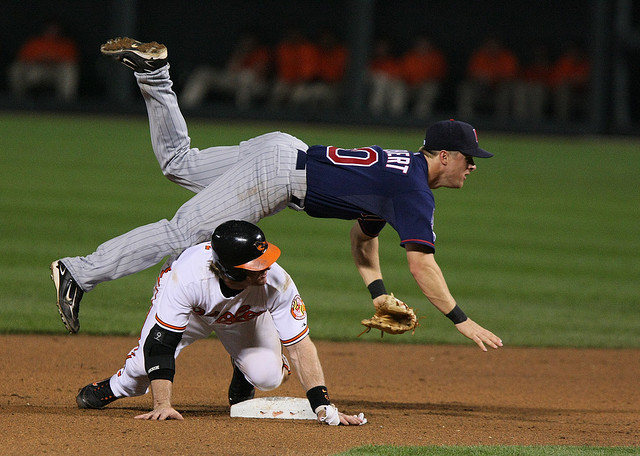Please transcribe the text information in this image. ERT 